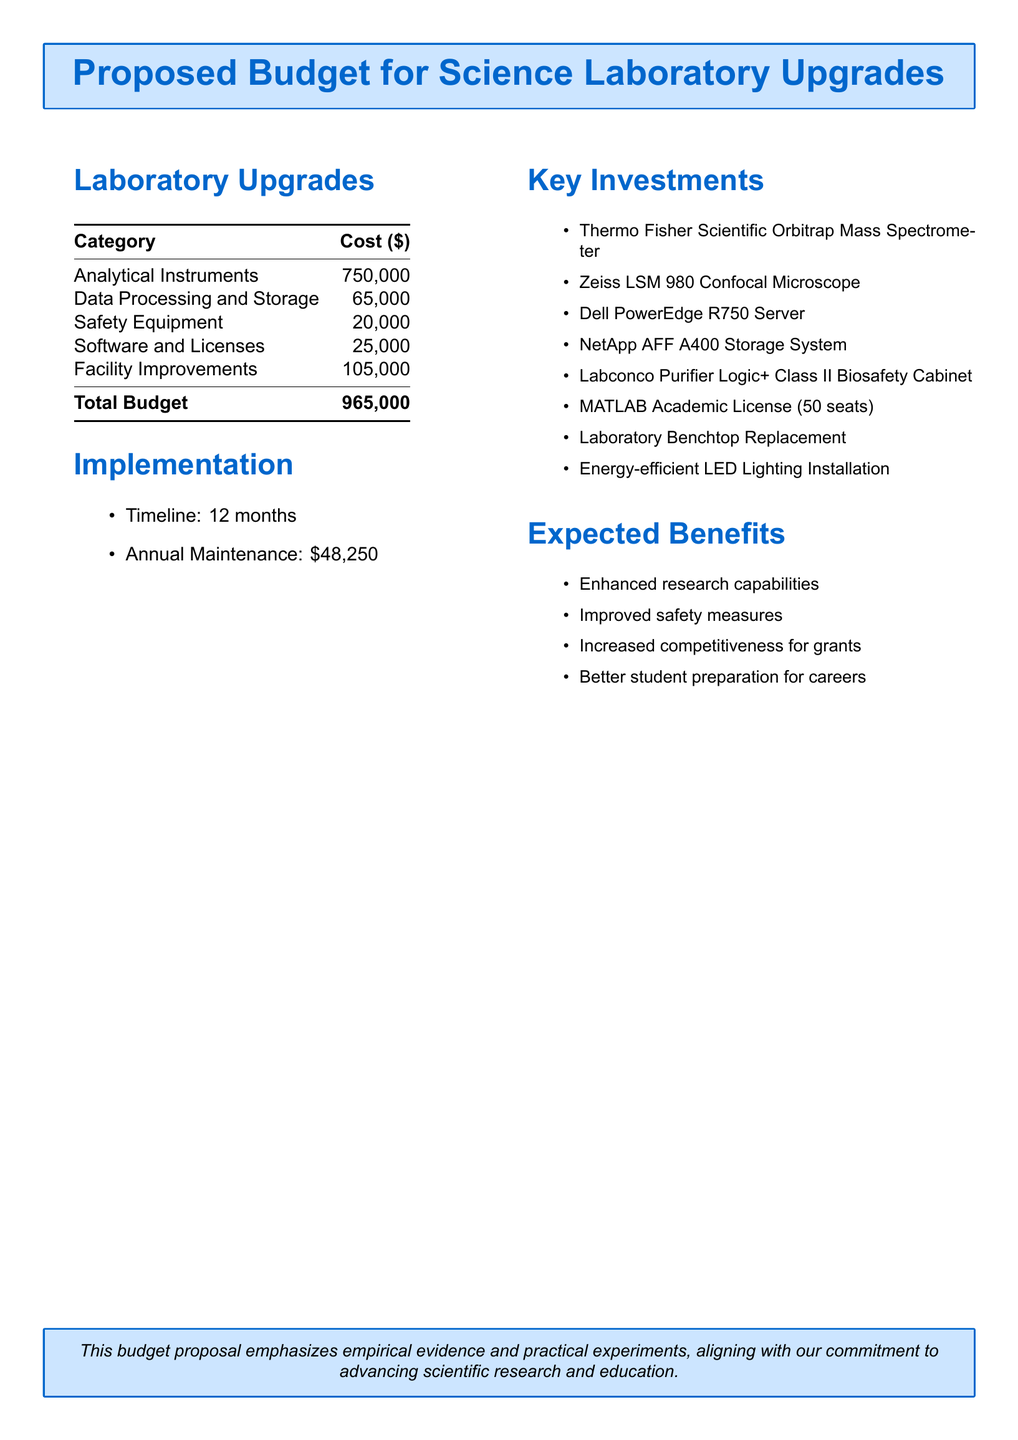What is the total budget proposed for laboratory upgrades? The total budget is listed at the bottom of the budget table in the document, summed from all categories of costs.
Answer: 965,000 How much is allocated for safety equipment? The safety equipment cost is a specific line item in the budget table.
Answer: 20,000 What instrument is the first key investment listed? The first item in the key investments list is mentioned at the beginning of that section.
Answer: Thermo Fisher Scientific Orbitrap Mass Spectrometer What is the timeline for implementation? The implementation timeline is explicitly stated under the implementation section of the document.
Answer: 12 months What is the annual maintenance cost? The annual maintenance cost is part of the implementation details included in the document.
Answer: 48,250 Which software license is included in the budget? The specific software and its detail can be found in the key investments part of the document, revealing the type of software included.
Answer: MATLAB Academic License (50 seats) How much is budgeted for analytical instruments? Analytical instruments are one of the categories in the budget, showing the total cost allocated for this category.
Answer: 750,000 What benefit relates to student preparation? The expected benefits section mentions a specific benefit regarding student skills and career readiness.
Answer: Better student preparation for careers What type of microscope is included as a key investment? A specific type of microscope is indicated in the key investments section that signifies its function and brand.
Answer: Zeiss LSM 980 Confocal Microscope 